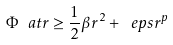<formula> <loc_0><loc_0><loc_500><loc_500>\Phi \ a t { r } \geq \frac { 1 } { 2 } { \beta } r ^ { 2 } + \ e p s { r } ^ { p }</formula> 